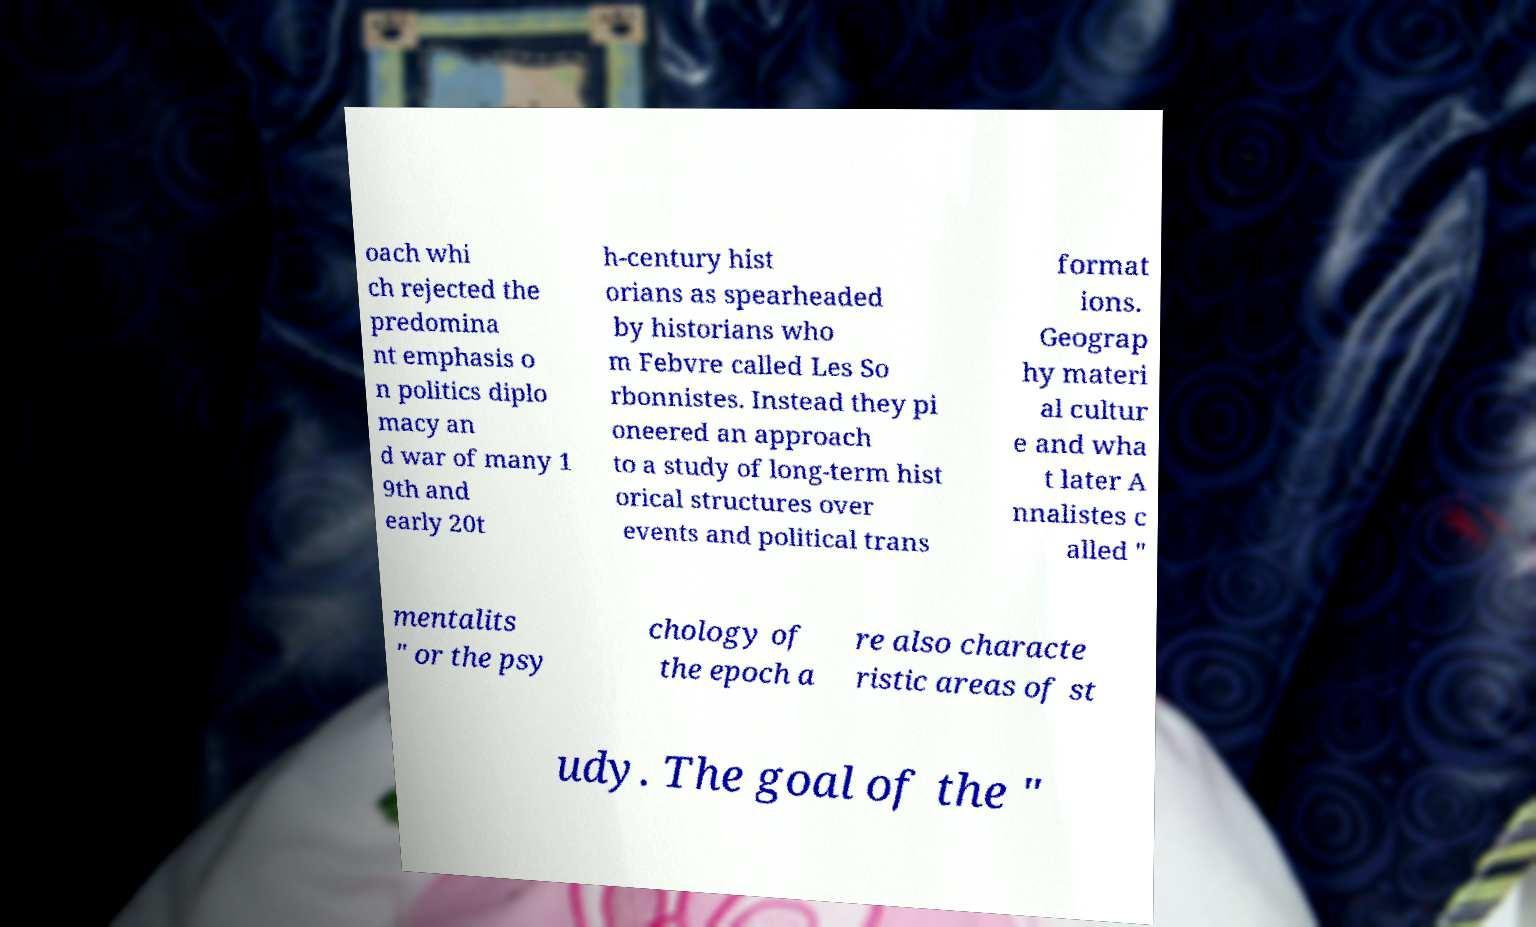Please identify and transcribe the text found in this image. oach whi ch rejected the predomina nt emphasis o n politics diplo macy an d war of many 1 9th and early 20t h-century hist orians as spearheaded by historians who m Febvre called Les So rbonnistes. Instead they pi oneered an approach to a study of long-term hist orical structures over events and political trans format ions. Geograp hy materi al cultur e and wha t later A nnalistes c alled " mentalits " or the psy chology of the epoch a re also characte ristic areas of st udy. The goal of the " 